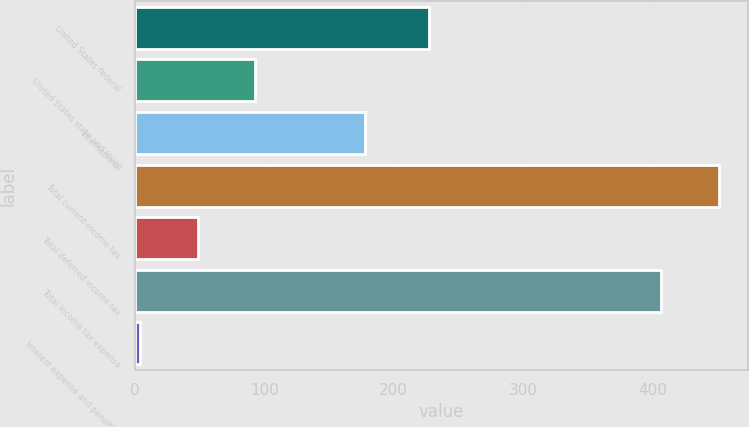Convert chart. <chart><loc_0><loc_0><loc_500><loc_500><bar_chart><fcel>United States federal<fcel>United States state and local<fcel>International<fcel>Total current income tax<fcel>Total deferred income tax<fcel>Total income tax expense<fcel>Interest expense and penalties<nl><fcel>227<fcel>92.4<fcel>178<fcel>451.2<fcel>48.2<fcel>407<fcel>4<nl></chart> 